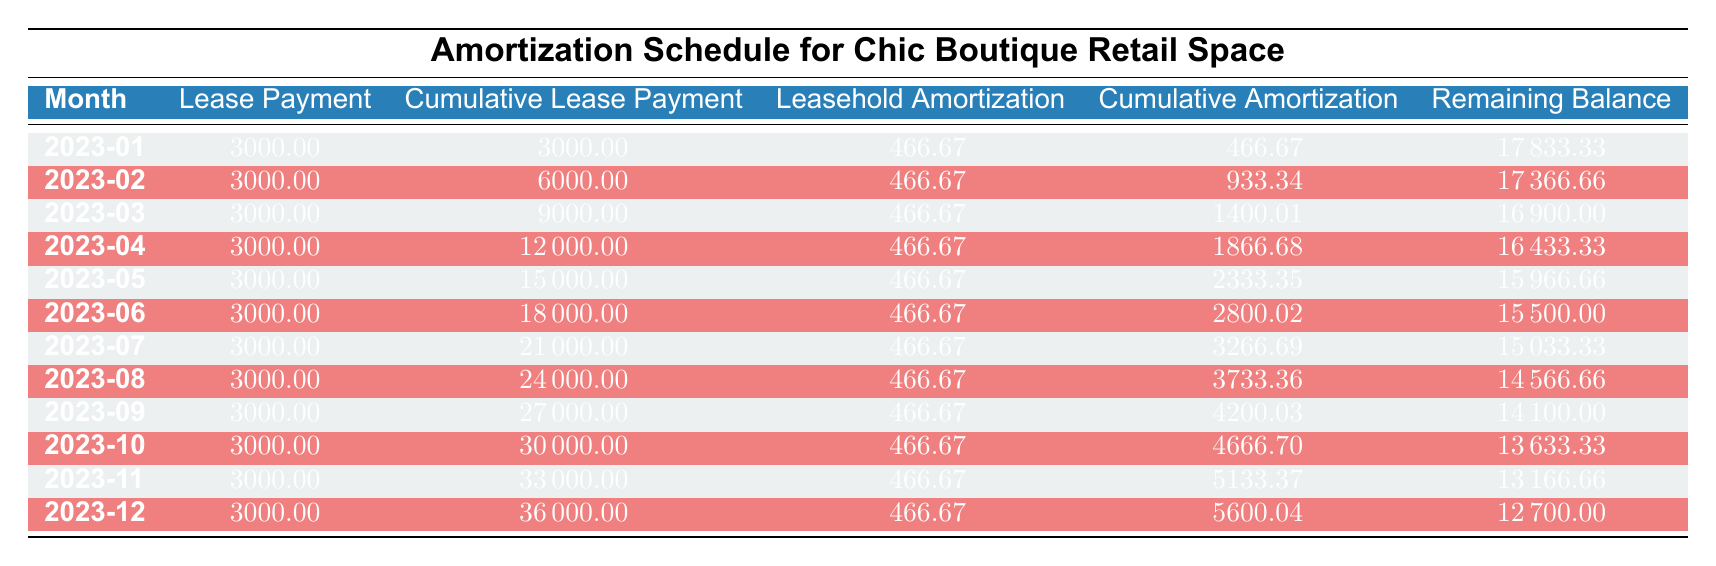What is the lease payment for January 2023? The table indicates that for January 2023, the lease payment listed is 3000.00.
Answer: 3000.00 What is the cumulative lease payment by December 2023? According to the table, the cumulative lease payment for December 2023 is 36000.00.
Answer: 36000.00 Is the leasehold amortization the same for each month? Yes, each month's leasehold amortization is consistently listed as 466.67 across all months in the table.
Answer: Yes What is the total cumulative amortization at the end of the lease year? Cumulative amortization for December is given as 5600.04. This means that by the end of the year, the total is 5600.04.
Answer: 5600.04 How much is the remaining balance at the end of September 2023? The remaining balance for September 2023 is recorded as 14100.00 in the table.
Answer: 14100.00 What is the total lease payment made from January to May? The cumulative lease payments from January to May are 3000 (Jan) + 3000 (Feb) + 3000 (Mar) + 3000 (Apr) + 3000 (May) = 15000.00.
Answer: 15000.00 By how much does the cumulative lease payment increase from January to October? The cumulative lease payment in January is 3000.00, and in October, it is 30000.00. The increase is 30000.00 - 3000.00 = 27000.00.
Answer: 27000.00 Is the monthly rent increasing over the lease term? No, based on the provided data, the monthly rent of 3000.00 remains constant throughout the lease term without any increase.
Answer: No What is the remaining balance after six months of payments? By June, the remaining balance is listed as 15500.00. This follows the monthly payments consistently seen in the table.
Answer: 15500.00 